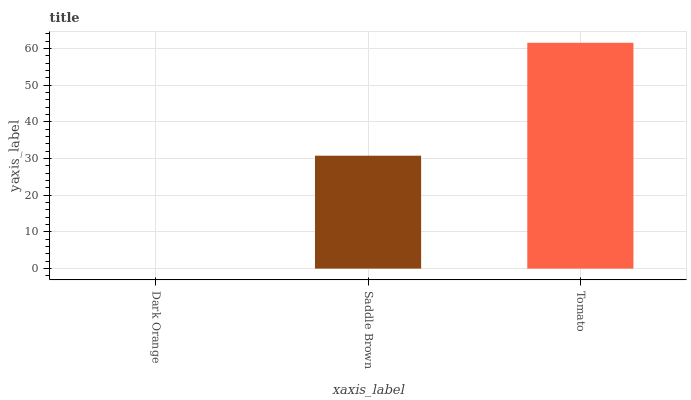Is Dark Orange the minimum?
Answer yes or no. Yes. Is Tomato the maximum?
Answer yes or no. Yes. Is Saddle Brown the minimum?
Answer yes or no. No. Is Saddle Brown the maximum?
Answer yes or no. No. Is Saddle Brown greater than Dark Orange?
Answer yes or no. Yes. Is Dark Orange less than Saddle Brown?
Answer yes or no. Yes. Is Dark Orange greater than Saddle Brown?
Answer yes or no. No. Is Saddle Brown less than Dark Orange?
Answer yes or no. No. Is Saddle Brown the high median?
Answer yes or no. Yes. Is Saddle Brown the low median?
Answer yes or no. Yes. Is Dark Orange the high median?
Answer yes or no. No. Is Tomato the low median?
Answer yes or no. No. 